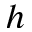<formula> <loc_0><loc_0><loc_500><loc_500>h</formula> 